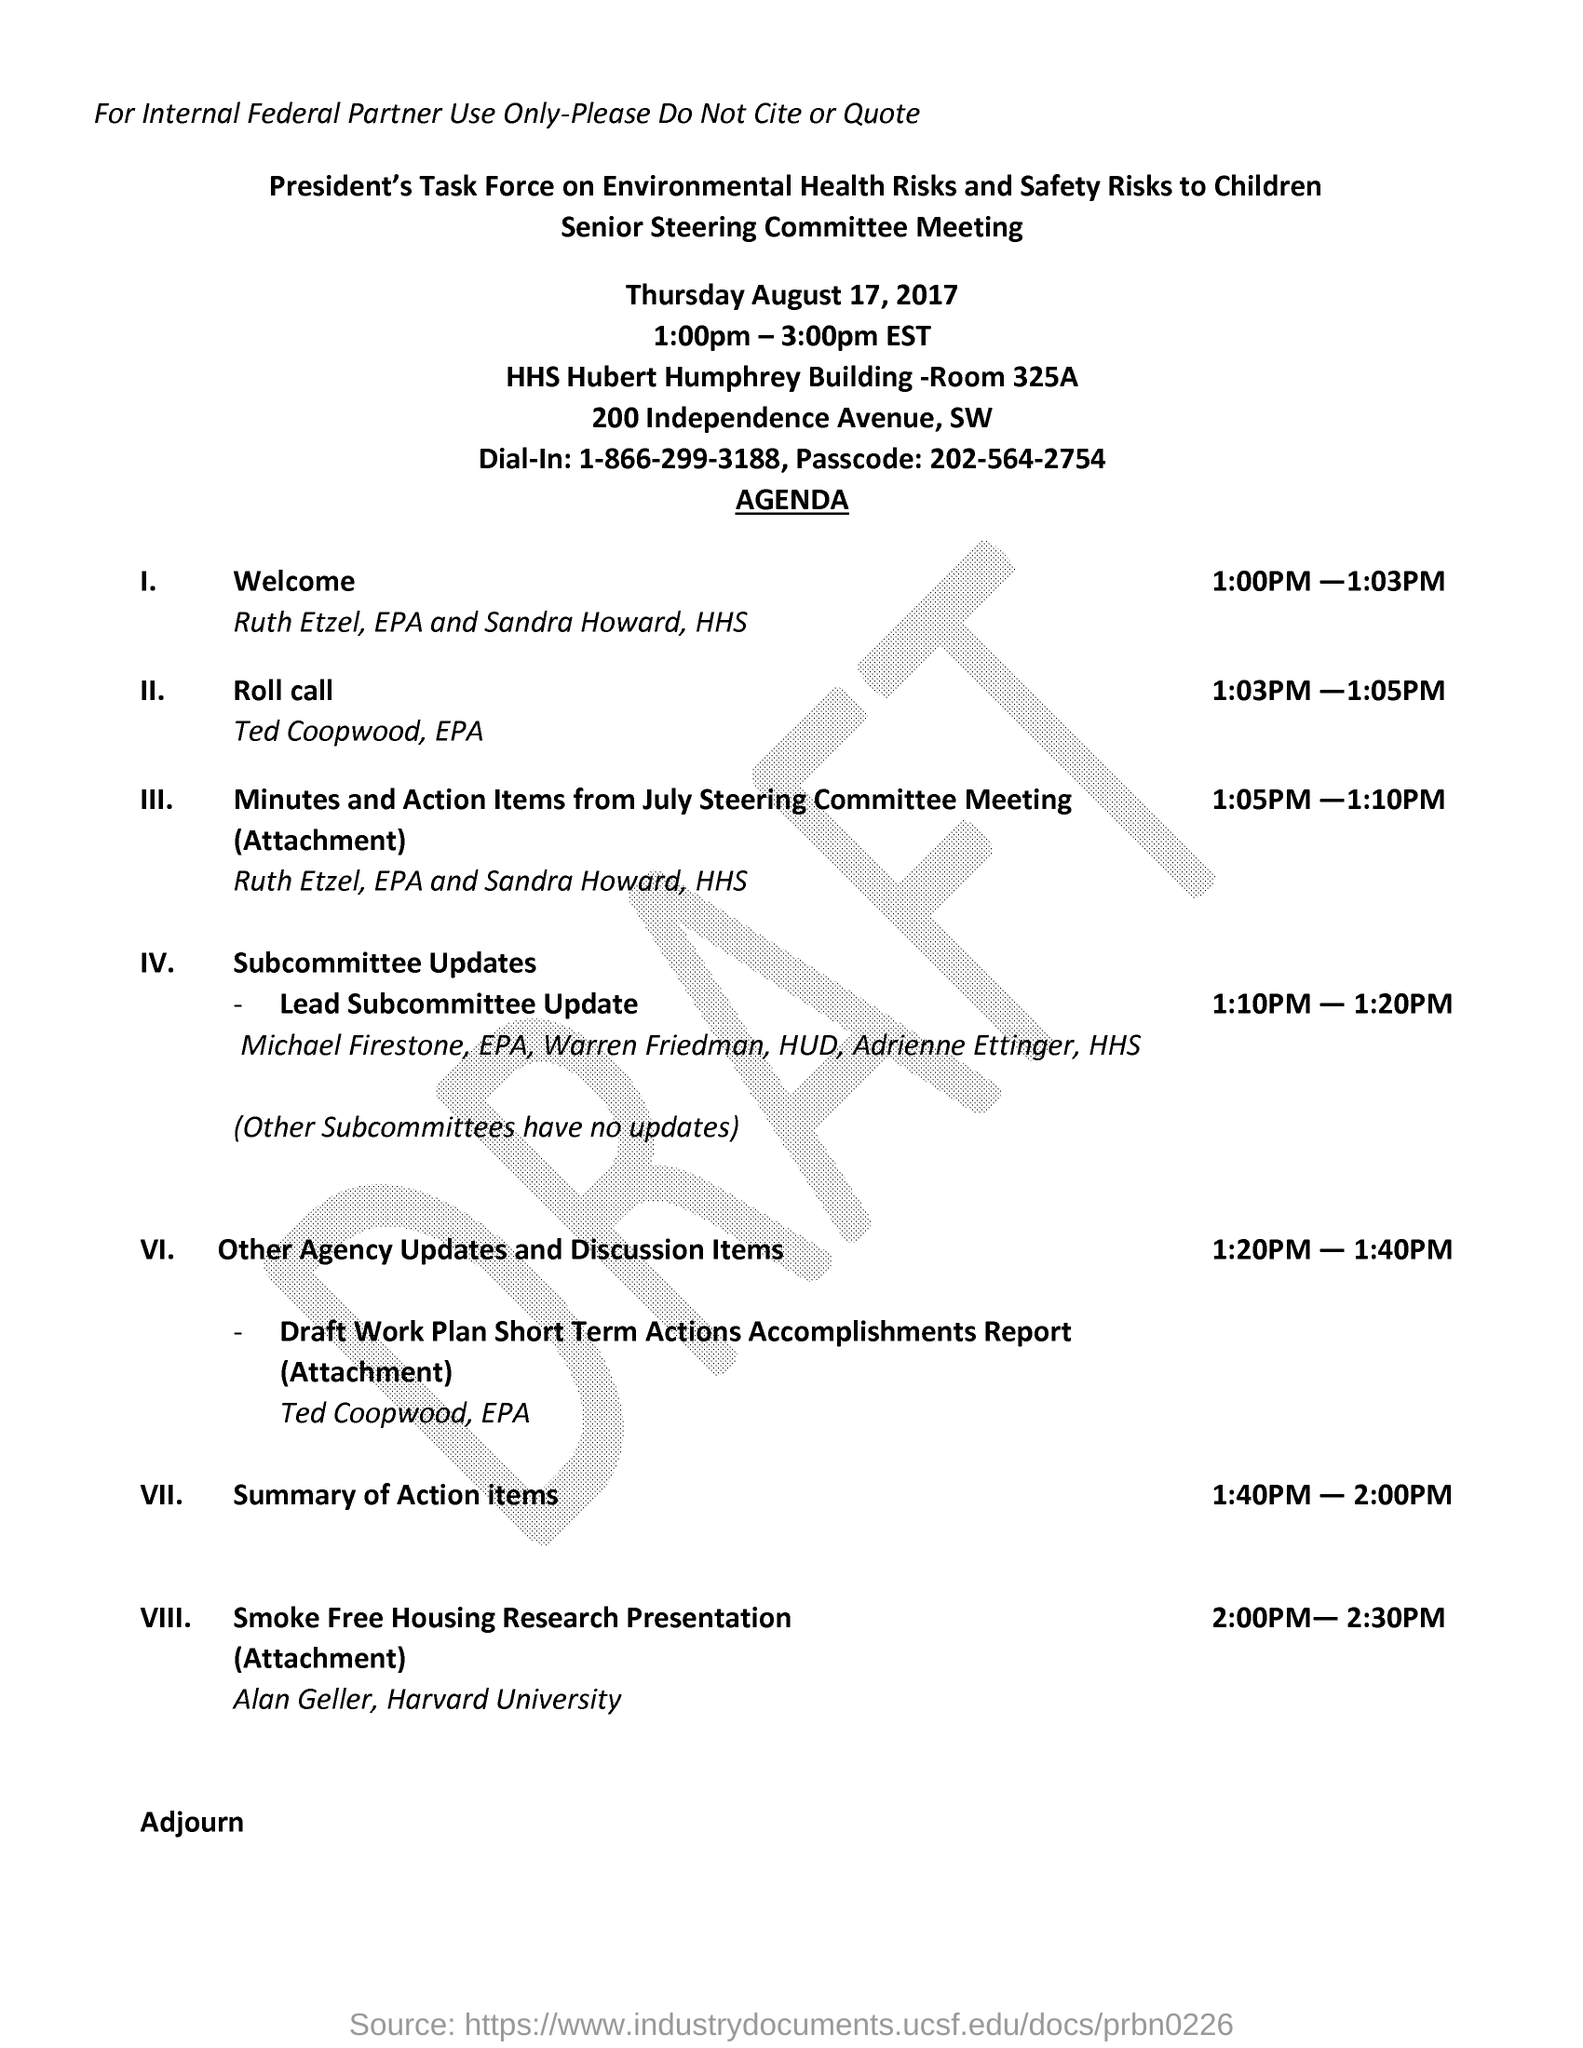On which date is the senior steering committee meeting conducted?
Your answer should be very brief. Thursday August 17, 2017. At what time is the senior steering committee meeting scheduled ?
Your answer should be compact. 1:00pm - 3:00pm EST. Between what timings the welcome is sheduled ?
Make the answer very short. 1:00PM-1:03PM. What is the agenda between 1:03pm-1:05pm?
Your response must be concise. Roll Call. What time is the subcommittee updates discussed?
Your answer should be compact. 1:10PM - 1:20PM. What is the agenda between 1:40 pm-2:00 pm ?
Keep it short and to the point. Summary of action items. What is the passcode number ?
Offer a very short reply. 202-564-2754. Where is the senior steering committee meeting held?
Give a very brief answer. HHS Hubert Humphery building -Room 325A. What is the given dail-in number ?
Make the answer very short. 1-866-299-3188. 